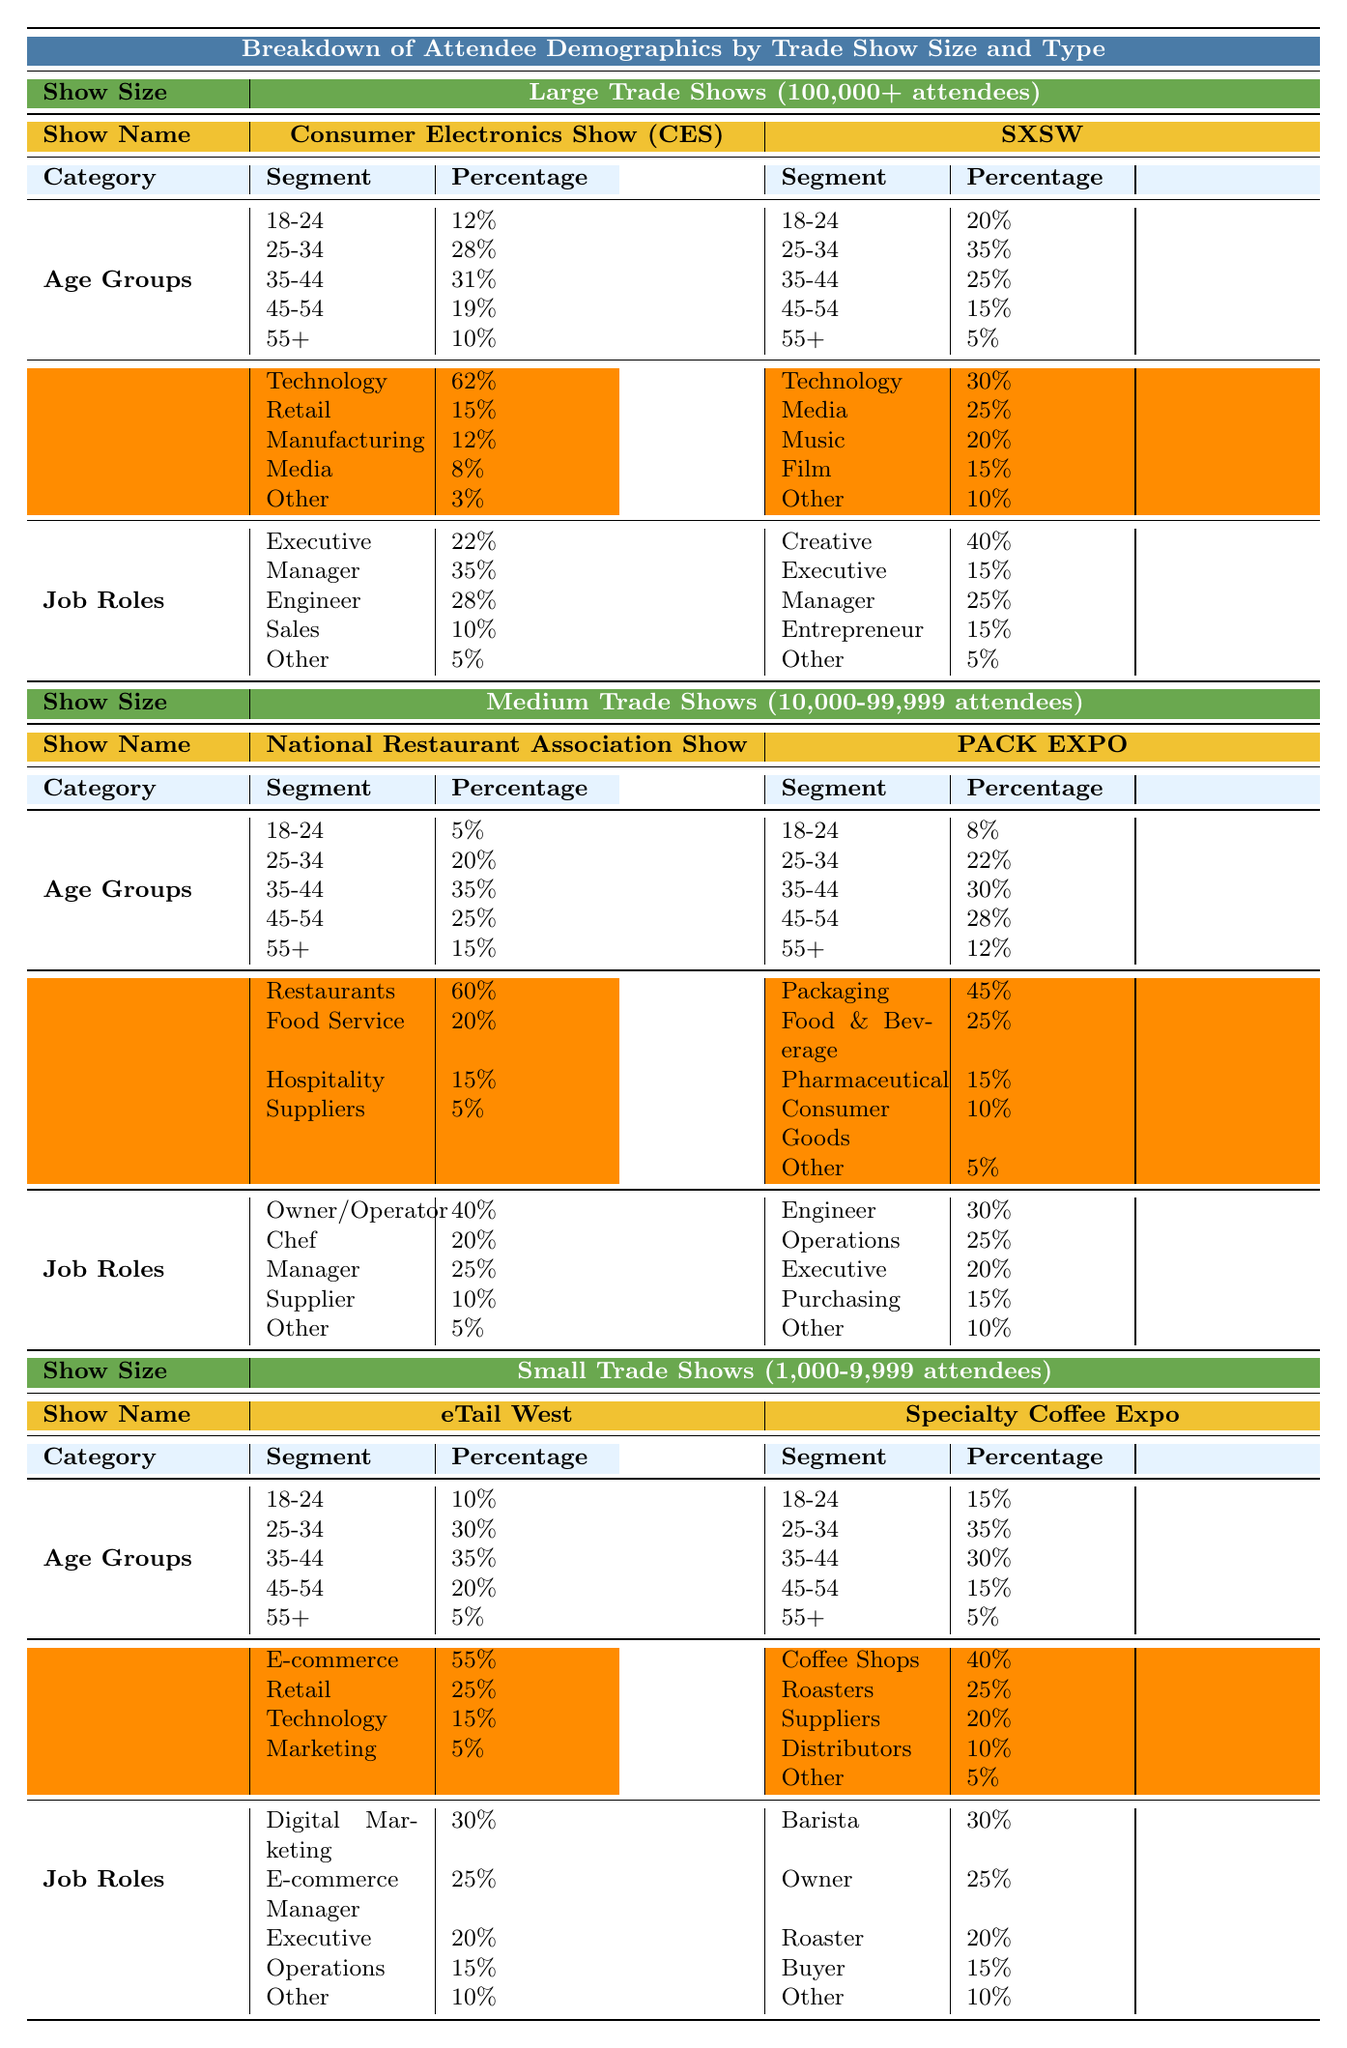What percentage of attendees at the Consumer Electronics Show (CES) are aged 35-44? The table indicates that within the age groups section for CES, 31% of attendees are in the 35-44 age group.
Answer: 31% Which job role has the highest percentage of attendees at SXSW? Reviewing the job roles section for SXSW, the Creative role has the highest percentage at 40%.
Answer: Creative What is the combined percentage of attendees aged 45-54 and 55+ at the National Restaurant Association Show? For the National Restaurant Association Show, the percentage of attendees aged 45-54 is 25% and for 55+ it is 15%, so the combined percentage is 25% + 15% = 40%.
Answer: 40% True or False: The majority of attendees at PACK EXPO are from the Food & Beverage industry. The table shows that 25% of attendees at PACK EXPO are from the Food & Beverage sector, which is not the majority (more than 50%) since the largest sector is Packaging with 45%.
Answer: False Which trade show has the highest percentage of attendees from the Technology sector? The data reveals that the Consumer Electronics Show (CES) has 62% of its attendees from the Technology sector, which is the highest among all listed shows.
Answer: Consumer Electronics Show (CES) Calculate the percentage of attendees who are 18-24 years old across all trade shows. For the 18-24 age group, the percentages are: CES (12%), SXSW (20%), National Restaurant Association Show (5%), PACK EXPO (8%), eTail West (10%), and Specialty Coffee Expo (15%). Adding these gives: 12% + 20% + 5% + 8% + 10% + 15% = 70%.
Answer: 70% What is the percentage of attendees in the age group of 35-44 at the Small Trade Shows? The table indicates that at eTail West, 35% are aged 35-44, and at Specialty Coffee Expo, it's also 30%. Since we need the percentage for both shows combined, it is not directly provided and requires more context.
Answer: 35% (eTail West) and 30% (Specialty Coffee Expo) Which job role at the National Restaurant Association Show has the lowest percentage? In the job roles section for the National Restaurant Association Show, the role with the lowest percentage is Other at 5%.
Answer: Other How does the 25-34 age group percentage at SXSW compare to that of the same age group at PACK EXPO? At SXSW, the percentage for the 25-34 age group is 35%, while at PACK EXPO, it is 22%. The comparison shows that 25-34 age group is more prevalent at SXSW than at PACK EXPO by 13% (35% - 22%).
Answer: SXSW has a higher prevalence by 13% What percentage of attendees at eTail West are from the E-commerce sector? The table shows that 55% of attendees at eTail West are from the E-commerce sector, which is the highest among listed sectors for that trade show.
Answer: 55% What is the overall percentage of Executive roles in both large trade shows combined? The Executive role has a percentage of 22% at CES and 15% at SXSW. The total percentage for both shows is 22% + 15% = 37%.
Answer: 37% 